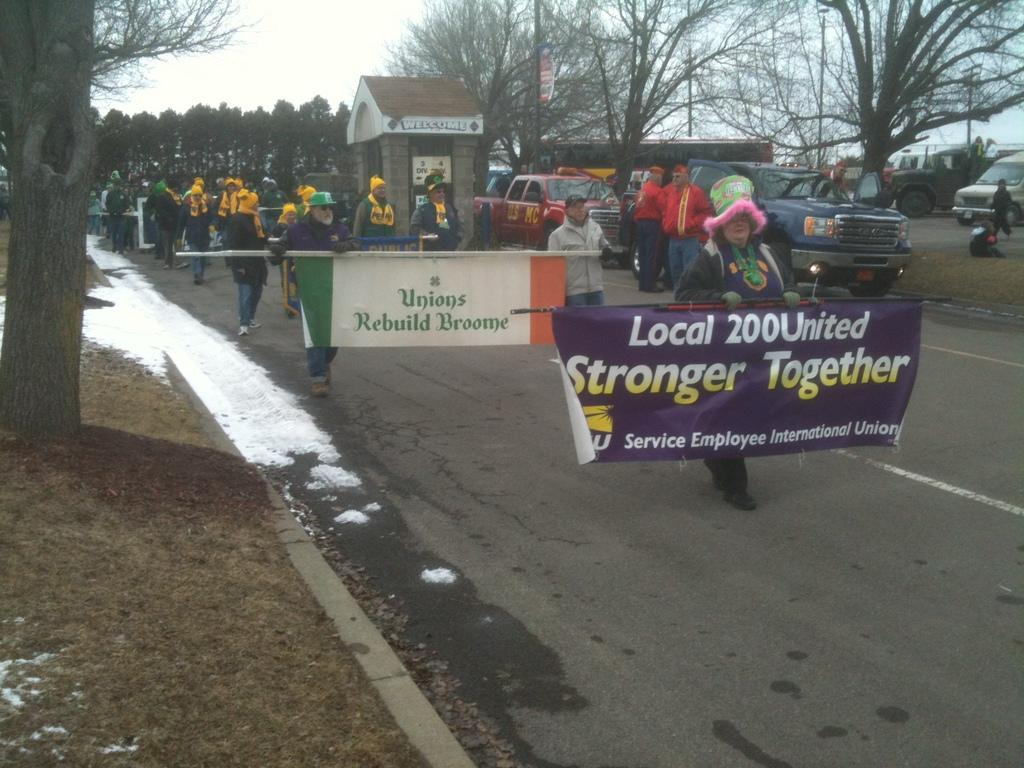<image>
Offer a succinct explanation of the picture presented. People holding a purple sign which says "Stronger Together". 